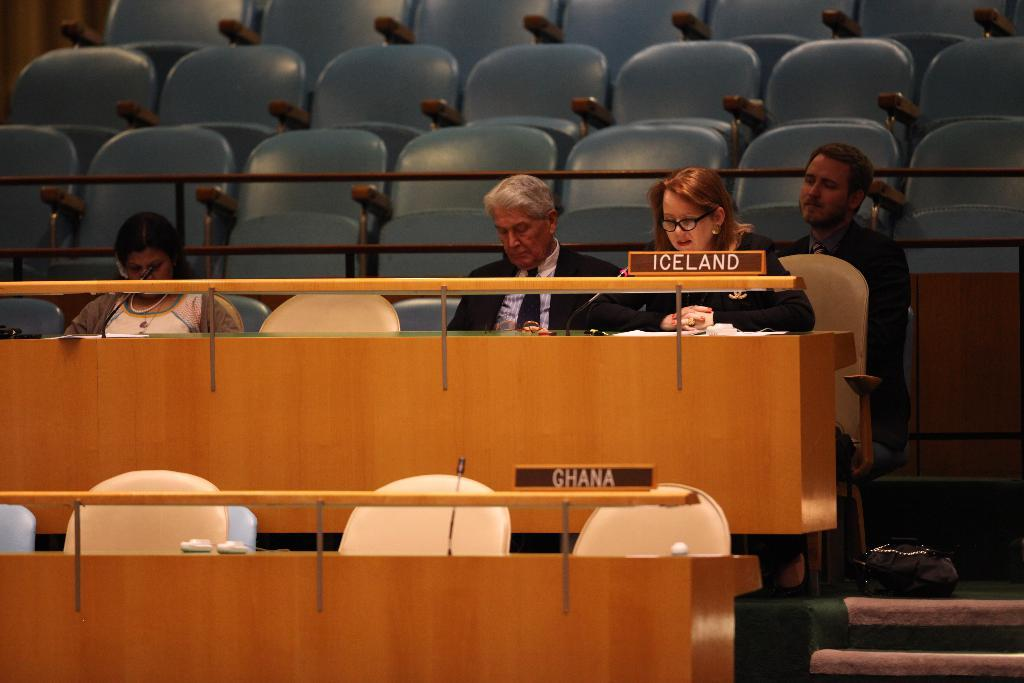<image>
Give a short and clear explanation of the subsequent image. A woman sits in a chair behind an Iceland nameplate. 